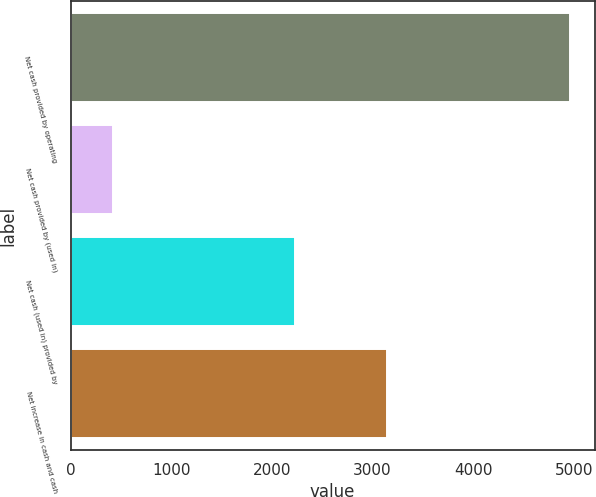Convert chart to OTSL. <chart><loc_0><loc_0><loc_500><loc_500><bar_chart><fcel>Net cash provided by operating<fcel>Net cash provided by (used in)<fcel>Net cash (used in) provided by<fcel>Net increase in cash and cash<nl><fcel>4958<fcel>419<fcel>2232<fcel>3145<nl></chart> 